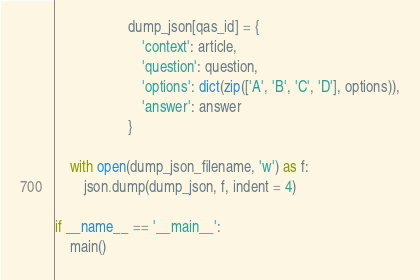Convert code to text. <code><loc_0><loc_0><loc_500><loc_500><_Python_>                    dump_json[qas_id] = {
                        'context': article,
                        'question': question,
                        'options': dict(zip(['A', 'B', 'C', 'D'], options)),
                        'answer': answer
                    }

    with open(dump_json_filename, 'w') as f:
        json.dump(dump_json, f, indent = 4)

if __name__ == '__main__':
    main()</code> 